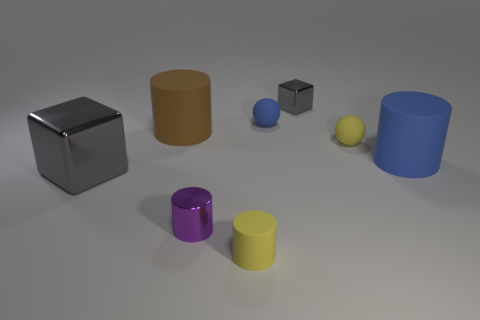What color is the metallic cube that is the same size as the purple metal cylinder?
Your answer should be compact. Gray. How big is the metal cube in front of the blue cylinder that is right of the blue rubber ball?
Offer a terse response. Large. There is another metal cube that is the same color as the small shiny cube; what is its size?
Make the answer very short. Large. How many other things are there of the same size as the yellow matte sphere?
Offer a very short reply. 4. How many blocks are there?
Make the answer very short. 2. Do the brown matte cylinder and the blue cylinder have the same size?
Give a very brief answer. Yes. What number of other things are the same shape as the purple shiny object?
Give a very brief answer. 3. There is a big cylinder that is right of the tiny gray object right of the brown thing; what is it made of?
Provide a short and direct response. Rubber. Are there any small purple things right of the yellow rubber sphere?
Your answer should be very brief. No. There is a yellow matte ball; does it have the same size as the cylinder that is to the right of the small yellow matte cylinder?
Keep it short and to the point. No. 